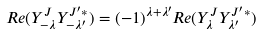<formula> <loc_0><loc_0><loc_500><loc_500>R e ( Y ^ { J } _ { - \lambda } Y ^ { J ^ { \prime } * } _ { - \lambda ^ { \prime } } ) = ( - 1 ) ^ { \lambda + \lambda ^ { \prime } } R e ( Y ^ { J } _ { \lambda } Y ^ { J ^ { \prime } * } _ { \lambda ^ { \prime } } )</formula> 